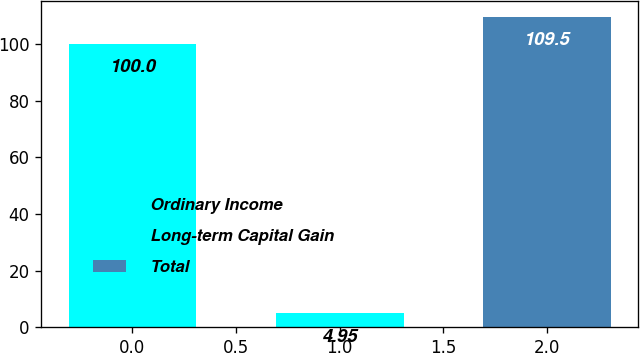<chart> <loc_0><loc_0><loc_500><loc_500><bar_chart><fcel>Ordinary Income<fcel>Long-term Capital Gain<fcel>Total<nl><fcel>100<fcel>4.95<fcel>109.5<nl></chart> 